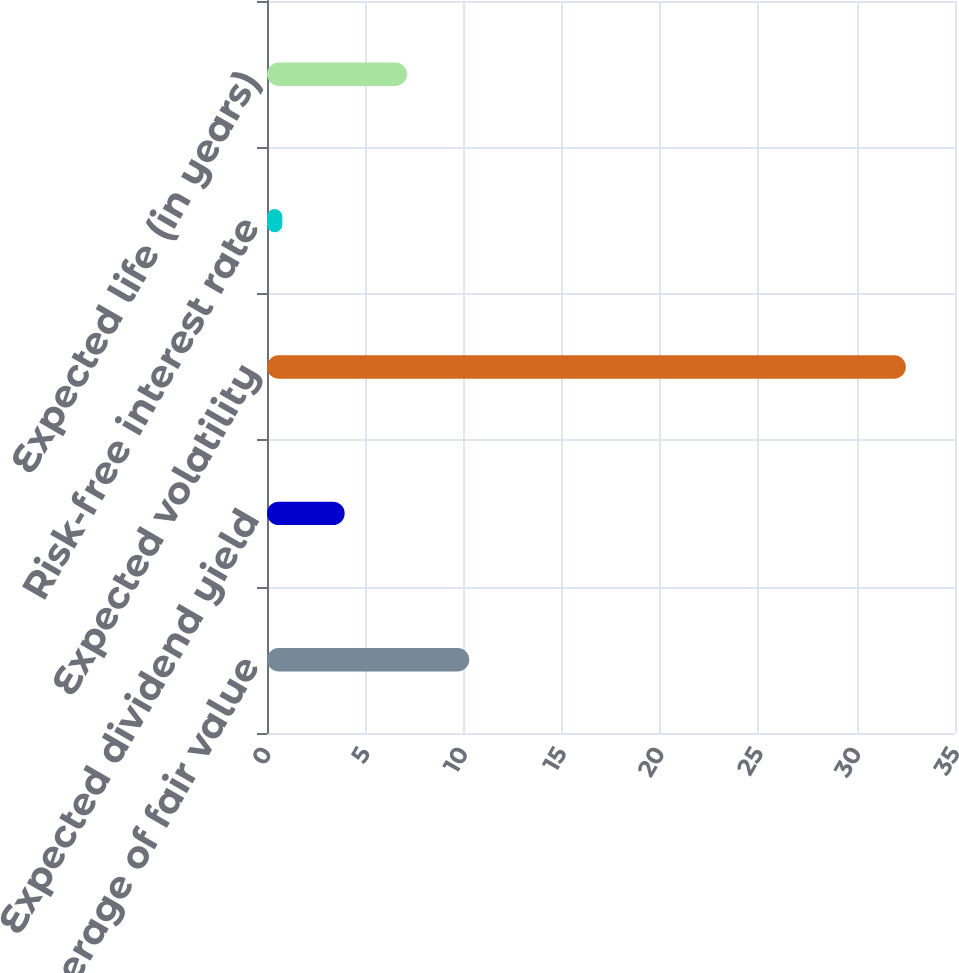Convert chart to OTSL. <chart><loc_0><loc_0><loc_500><loc_500><bar_chart><fcel>Weighted average of fair value<fcel>Expected dividend yield<fcel>Expected volatility<fcel>Risk-free interest rate<fcel>Expected life (in years)<nl><fcel>10.29<fcel>3.95<fcel>32.5<fcel>0.78<fcel>7.12<nl></chart> 